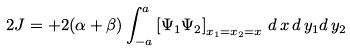<formula> <loc_0><loc_0><loc_500><loc_500>2 J = + 2 ( \alpha + \beta ) \int _ { - a } ^ { a } \left [ \Psi _ { 1 } \Psi _ { 2 } \right ] _ { x _ { 1 } = x _ { 2 } = x } \, d \, x \, d \, y _ { 1 } d \, y _ { 2 }</formula> 